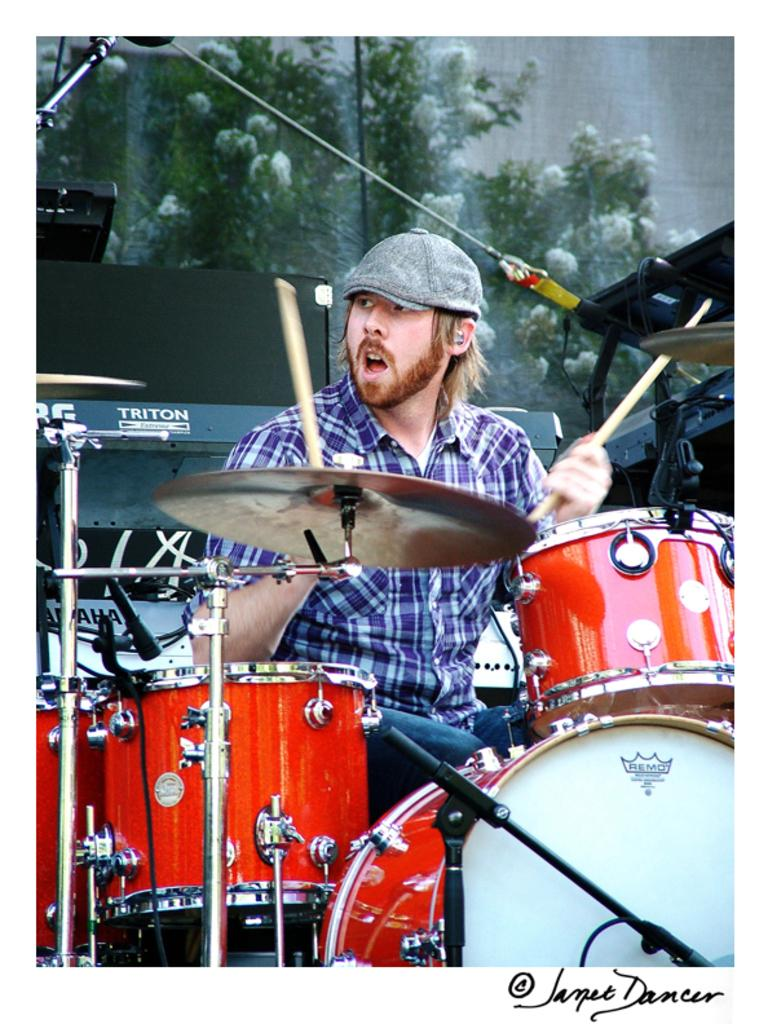What is the main subject of the image? The main subject of the image is a man seated in the middle. What is the man wearing on his head? The man is wearing a cap. What objects are in front of the man? There are drums and other musical instruments in front of the man. What time is it in the bedroom according to the clock in the image? There is no clock or bedroom present in the image; it features a man seated with musical instruments in front of him. 